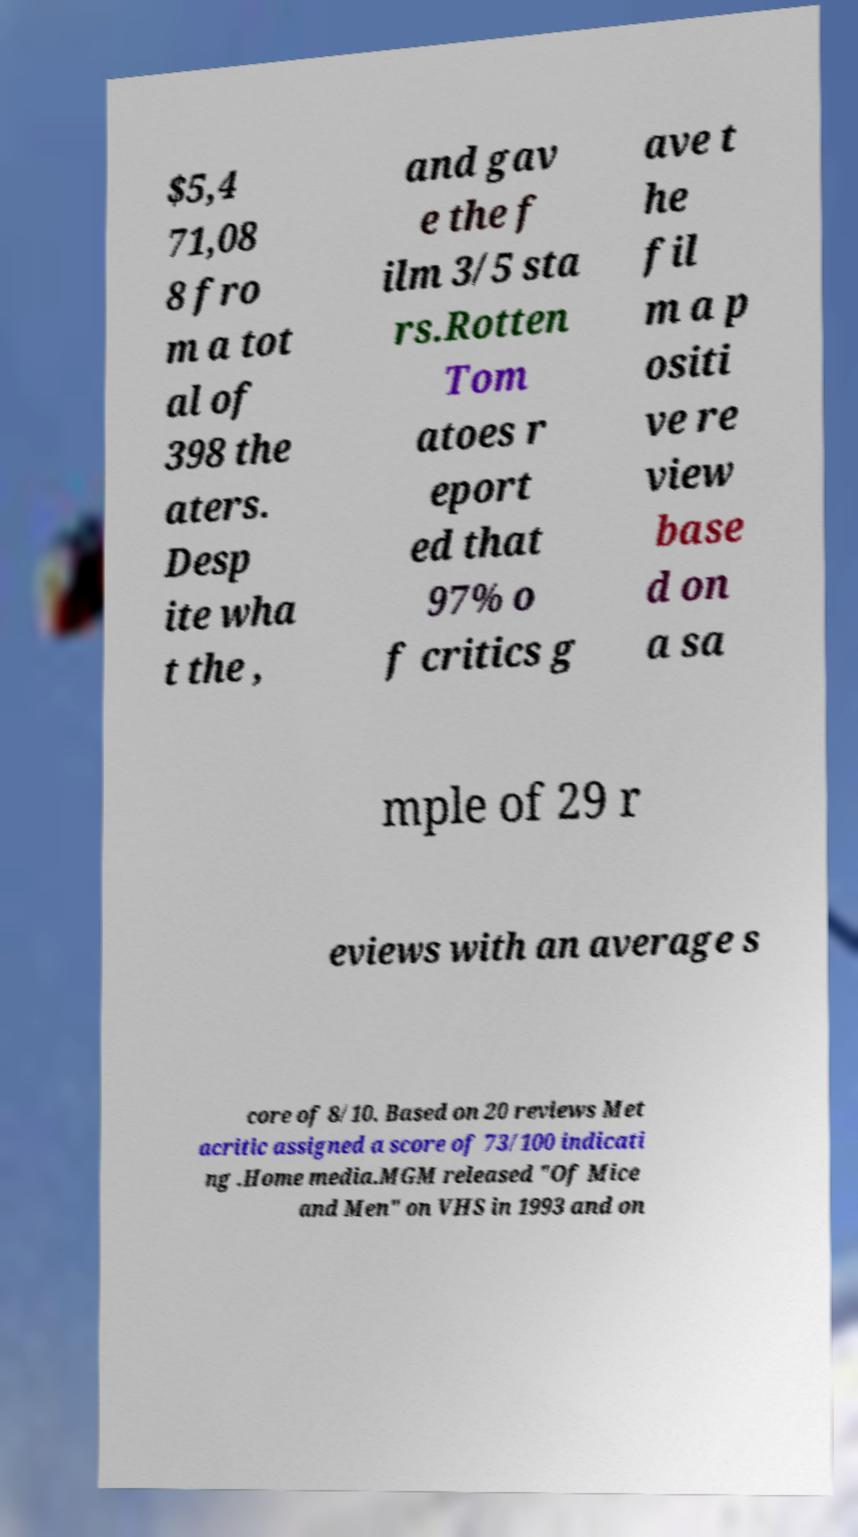Could you assist in decoding the text presented in this image and type it out clearly? $5,4 71,08 8 fro m a tot al of 398 the aters. Desp ite wha t the , and gav e the f ilm 3/5 sta rs.Rotten Tom atoes r eport ed that 97% o f critics g ave t he fil m a p ositi ve re view base d on a sa mple of 29 r eviews with an average s core of 8/10. Based on 20 reviews Met acritic assigned a score of 73/100 indicati ng .Home media.MGM released "Of Mice and Men" on VHS in 1993 and on 